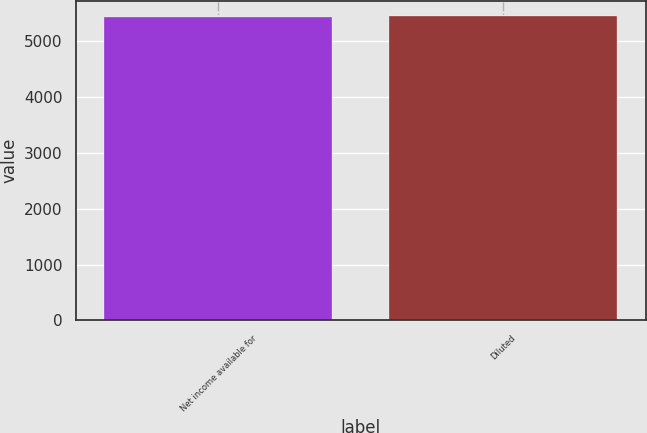Convert chart to OTSL. <chart><loc_0><loc_0><loc_500><loc_500><bar_chart><fcel>Net income available for<fcel>Diluted<nl><fcel>5446<fcel>5452<nl></chart> 